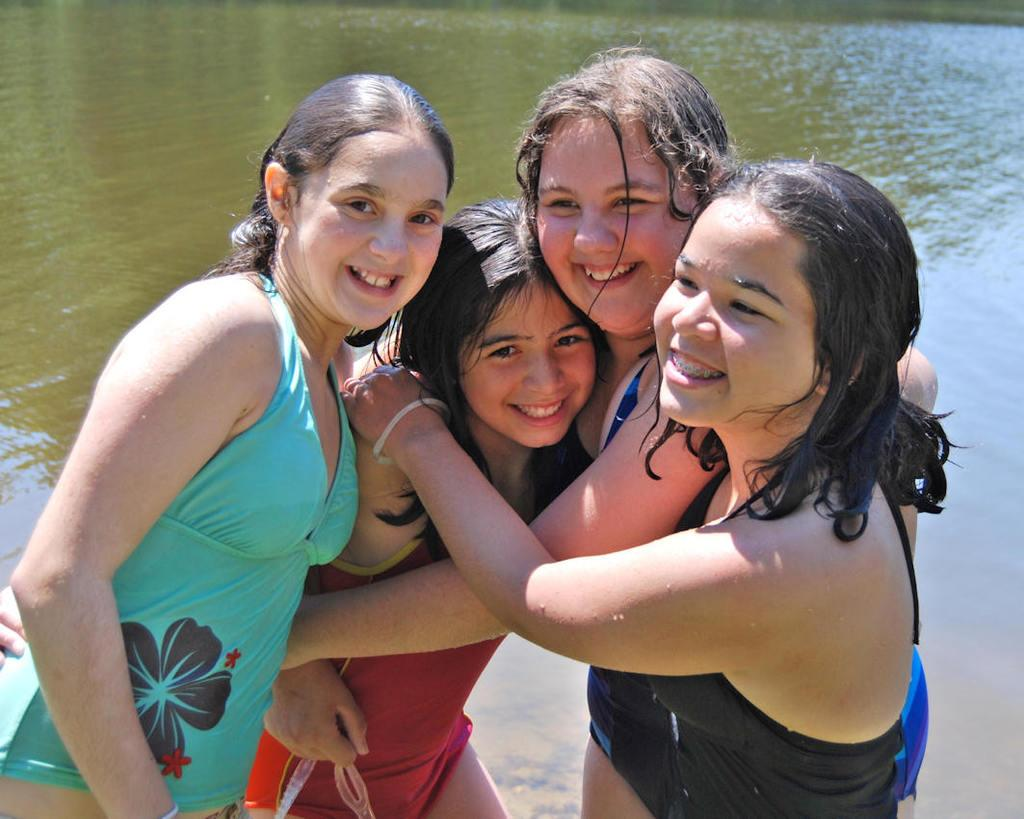What is the main subject in the foreground of the picture? There is a group of girls in the foreground of the picture. Can you describe the background of the image? There is a water body visible in the image. What type of pain can be seen on the girls' faces in the image? There is no indication of pain on the girls' faces in the image. What type of bushes are present near the water body in the image? There is no mention of bushes in the image; only a water body is mentioned. 